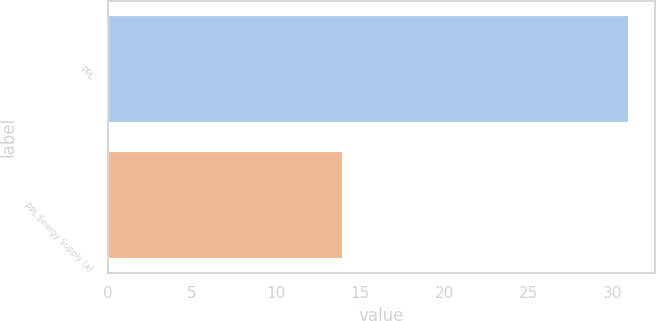<chart> <loc_0><loc_0><loc_500><loc_500><bar_chart><fcel>PPL<fcel>PPL Energy Supply (a)<nl><fcel>31<fcel>14<nl></chart> 